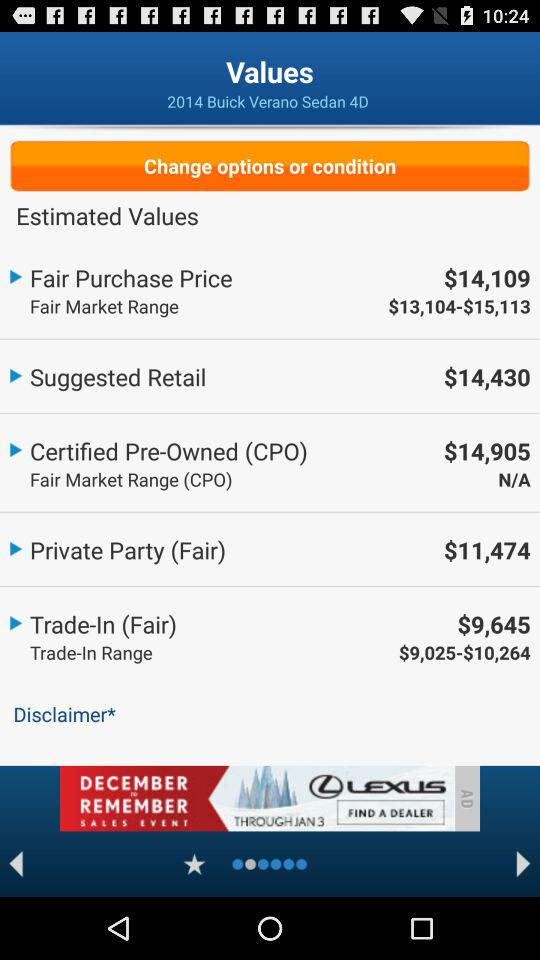What is the price of certified pre-owned? The price is $14,905. 